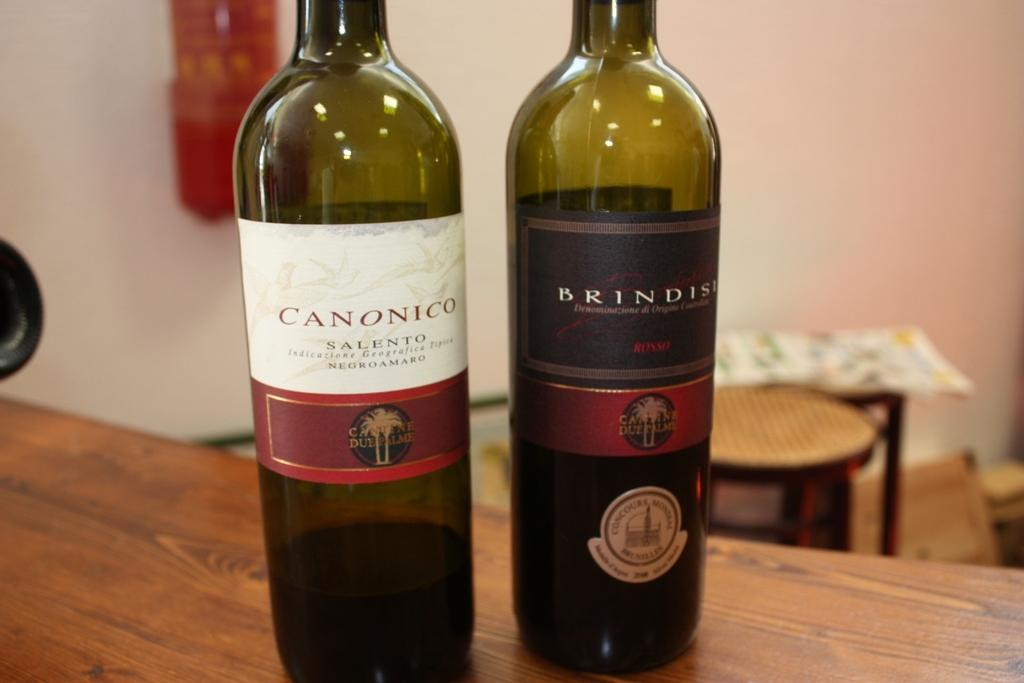<image>
Offer a succinct explanation of the picture presented. a canonico bottle that is on a table 